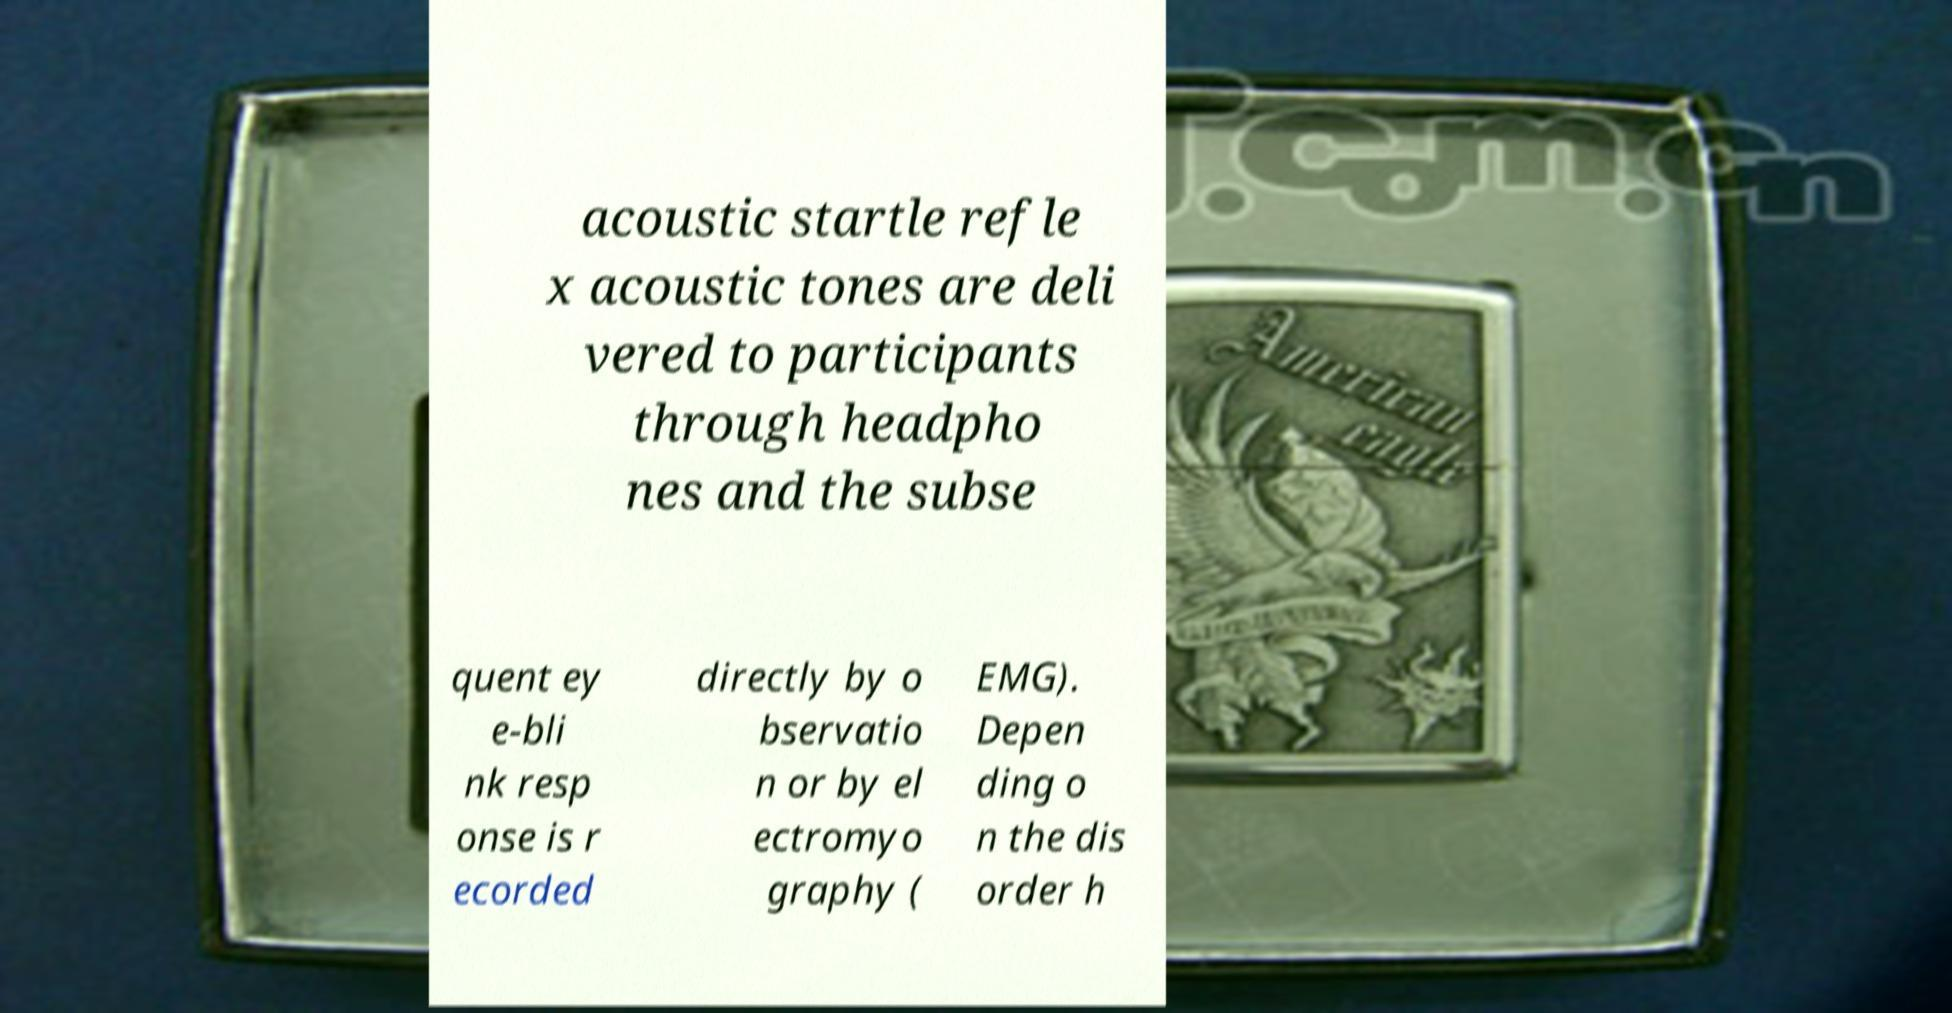I need the written content from this picture converted into text. Can you do that? acoustic startle refle x acoustic tones are deli vered to participants through headpho nes and the subse quent ey e-bli nk resp onse is r ecorded directly by o bservatio n or by el ectromyo graphy ( EMG). Depen ding o n the dis order h 